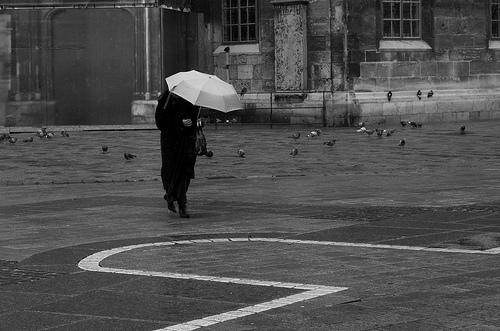Comment on the elements of the building in the picture, specifically focusing on its lower portion. The building has stones at the bottom, a window set into the stone wall, and three pigeons perched on a ledge. Examine the image and tell me how many distinct groups of pigeons can be identified. Five distinct groups of pigeons can be identified in the image. Enumerate three characteristics of the depicted person's ensemble. Black jacket, black boots, and a white umbrella. Identify the primary action of the person in the image and the item they're using. A person is walking in the rain while holding a white umbrella. Describe the attire and accessories of the person walking, using more poetic language. Cloaked in somber black garments, the person strides through the melancholic rain, a delicate, light-colored umbrella providing fragile shelter. Explain a possible sentiment that a viewer may infer from this black and white photograph. A viewer might feel a sense of melancholy or solitude, given the dreary, rainy atmosphere and the person walking alone. In a single sentence, describe the weather and the surface the person in the image is walking on. It's a rainy day, and the person is walking on a wet cobblestone road with white lines. What might be one possible reason for the presence of so many pigeons in the square? The pigeons may be gathering in the square to beg for food or find shelter from the rain. Provide a brief summary of the scene, highlighting the presence of birds. Person walking with a white umbrella in the rain amidst black and white pigeons on a cobblestone road. List three things that you can find on the ground in this scene. Pigeons, white lines, and cobblestones. Is the person dressed in all black or multiple colors? all black How does the person appear to manage the wet weather condition? by holding an umbrella What is the purpose of the umbrella? to protect from rain Describe the scene in the image. a person walking in the rain holding a white umbrella, surrounded by pigeons on the ground with a building in the background Are the white lines on the ground straight or curved? straight In the center of the frame, there's a beautiful fountain surrounded by flowers. Take a moment to appreciate the floral arrangement. This instruction is misleading because there is no mention of a fountain or flowers in the image. All mentioned objects are related to a person, pigeons, and architectural elements, not nature or decorative elements. What type of footwear is the person wearing? black boots What is the main subject holding in their hand? a white umbrella Which of the following is the person wearing? (a) a black jacket (b) a green jacket (c) a red jacket a black jacket What is the weather condition in the image? raining Notice the playful dog jumping around near the pigeons, trying to catch them. Can you see its wagging tail and floppy ears? This instruction is misleading as no dog has been mentioned in the image information. The focus is on a person and pigeons, not any other animals, so it would be impossible to find such a dog. What is found on the ground that is light in color in the image? white lines What is the color of the umbrella being held by the person? white Give a creative caption for the scene. person trying to avoid bird poop on a rainy day Identify the birds next to the person. pigeons Describe the object being held by the person. a white umbrella in the rain Observe the belfry of the old cathedral in the background, towering above everything else. The intricate gothic architecture is worth admiring. This instruction is misleading as there is no mention of any cathedral or gothic architecture in the image. The provided details focus on a person, pigeons, and various architecture elements that do not resemble a cathedral. How many pigeons are perched on the ledge at the bottom of the wall? three Are the birds on the ground or in the air? on the ground Can you find the red car in the left corner of the image? Focus on the shiny red paint. This instruction is misleading as there is no mention of any car in the image, let alone a red one. Additionally, the photo is described as being black and white, so the presence of color is impossible. Is the person walking or standing still? walking Could you point out the cute couple holding hands and sharing an umbrella in the top right section of the photo? They look so in love. This instruction is misleading because, although there is a person with an umbrella, there is no mention of a couple in the image details. The scene seems to be of a solitary person walking in the rain, not a romantic moment between two people. What type of surface are the pigeons walking on? cobblestone road Look for the little boy wearing a blue raincoat, standing at the edge of the photo, staring at the pigeons. He seems fascinated by the birds. This instruction is misleading because the image is black and white, and there is no mention of a little boy in the details. The focus is on a person with an umbrella, pigeons, and architectural elements – no mention of a child or colorful clothing. How would you describe the color scheme of the photo? black and white 